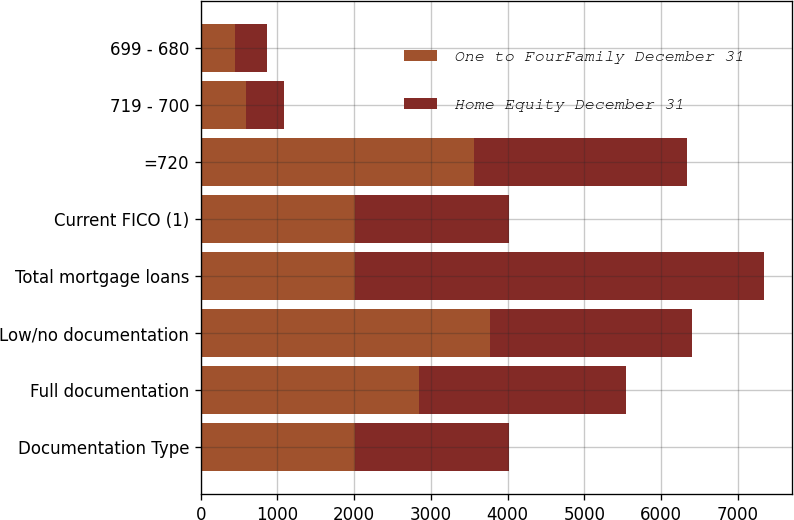<chart> <loc_0><loc_0><loc_500><loc_500><stacked_bar_chart><ecel><fcel>Documentation Type<fcel>Full documentation<fcel>Low/no documentation<fcel>Total mortgage loans<fcel>Current FICO (1)<fcel>=720<fcel>719 - 700<fcel>699 - 680<nl><fcel>One to FourFamily December 31<fcel>2011<fcel>2845.6<fcel>3770.2<fcel>2011<fcel>2011<fcel>3557.6<fcel>585.2<fcel>448.6<nl><fcel>Home Equity December 31<fcel>2011<fcel>2699.2<fcel>2629.5<fcel>5328.7<fcel>2011<fcel>2780.2<fcel>497.7<fcel>408.8<nl></chart> 